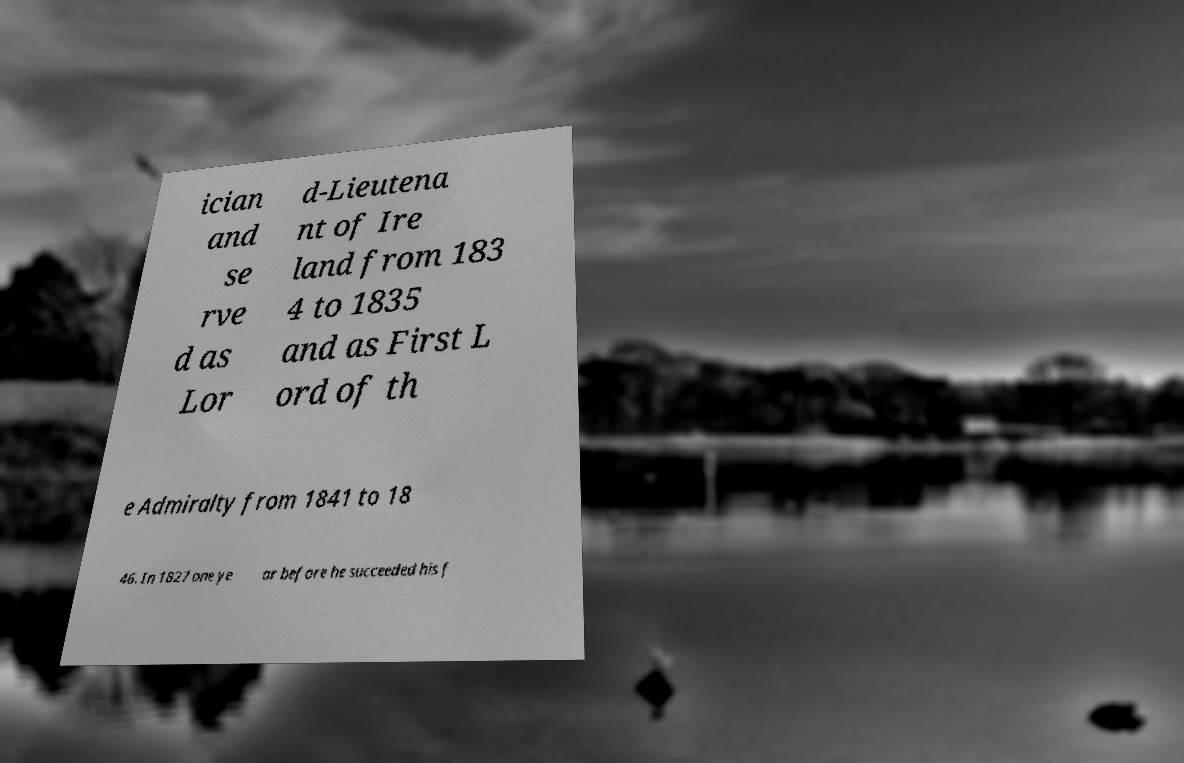I need the written content from this picture converted into text. Can you do that? ician and se rve d as Lor d-Lieutena nt of Ire land from 183 4 to 1835 and as First L ord of th e Admiralty from 1841 to 18 46. In 1827 one ye ar before he succeeded his f 